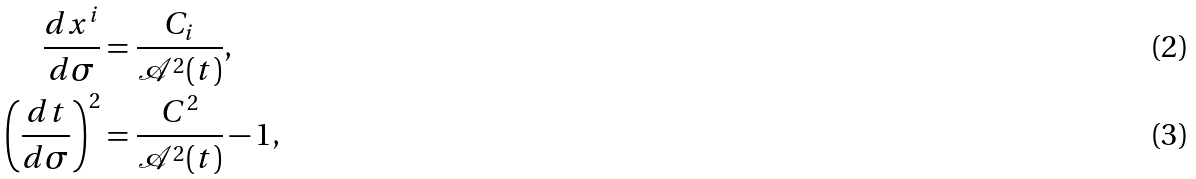<formula> <loc_0><loc_0><loc_500><loc_500>\frac { d x ^ { i } } { d \sigma } & = \frac { C _ { i } } { \mathcal { A } ^ { 2 } ( t ) } , \\ \left ( \frac { d t } { d \sigma } \right ) ^ { 2 } & = \frac { C ^ { 2 } } { \mathcal { A } ^ { 2 } ( t ) } - 1 ,</formula> 